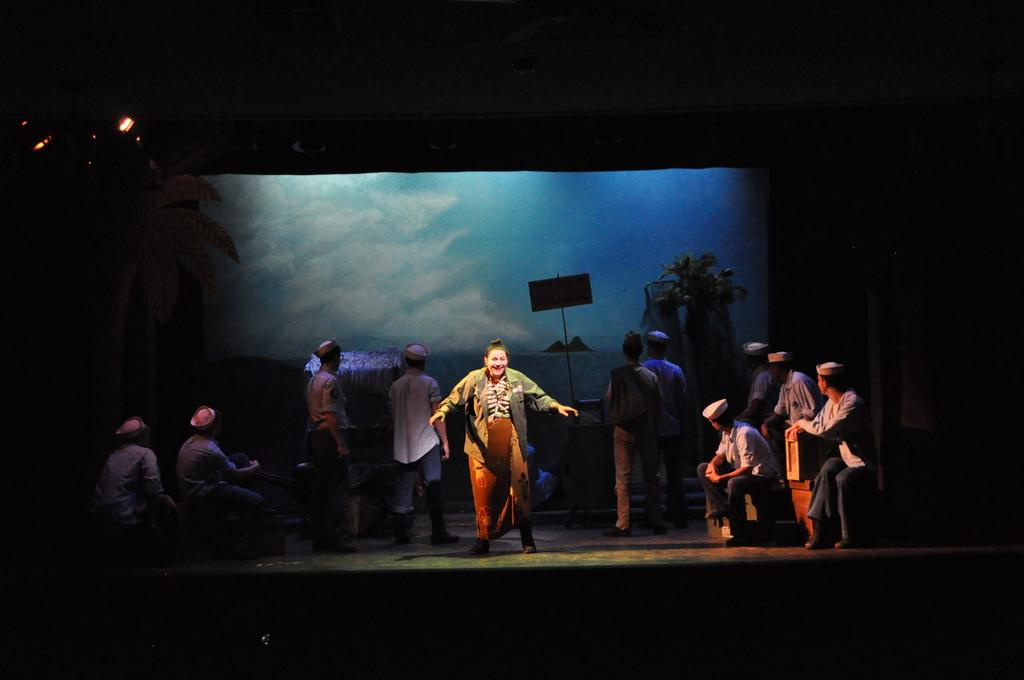What is happening in the image? There is an act playing on a stage in the image. Can you describe the setting of the image? The setting is a stage where a performance is taking place. What might be the purpose of the act on the stage? The purpose of the act on the stage could be for entertainment or a presentation. How far is the waste disposal unit from the stage in the image? There is no mention of a waste disposal unit in the image, so it cannot be determined how far it is from the stage. 